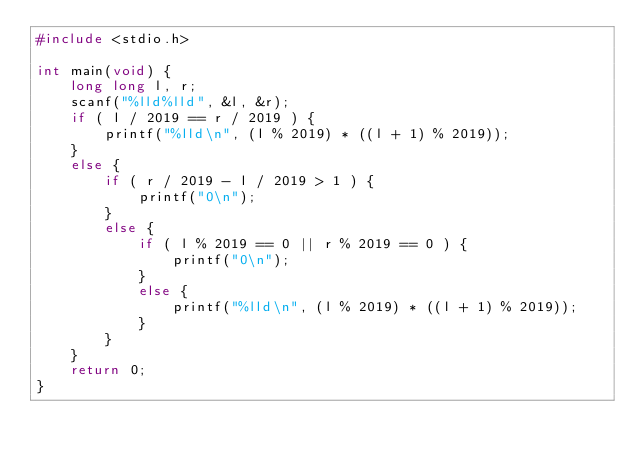Convert code to text. <code><loc_0><loc_0><loc_500><loc_500><_C_>#include <stdio.h>

int main(void) {
    long long l, r;
    scanf("%lld%lld", &l, &r);
    if ( l / 2019 == r / 2019 ) {
        printf("%lld\n", (l % 2019) * ((l + 1) % 2019));
    }
    else {
        if ( r / 2019 - l / 2019 > 1 ) {
            printf("0\n");
        }
        else {
            if ( l % 2019 == 0 || r % 2019 == 0 ) {
                printf("0\n");
            }
            else {
                printf("%lld\n", (l % 2019) * ((l + 1) % 2019));
            }
        }
    }
    return 0;
}</code> 